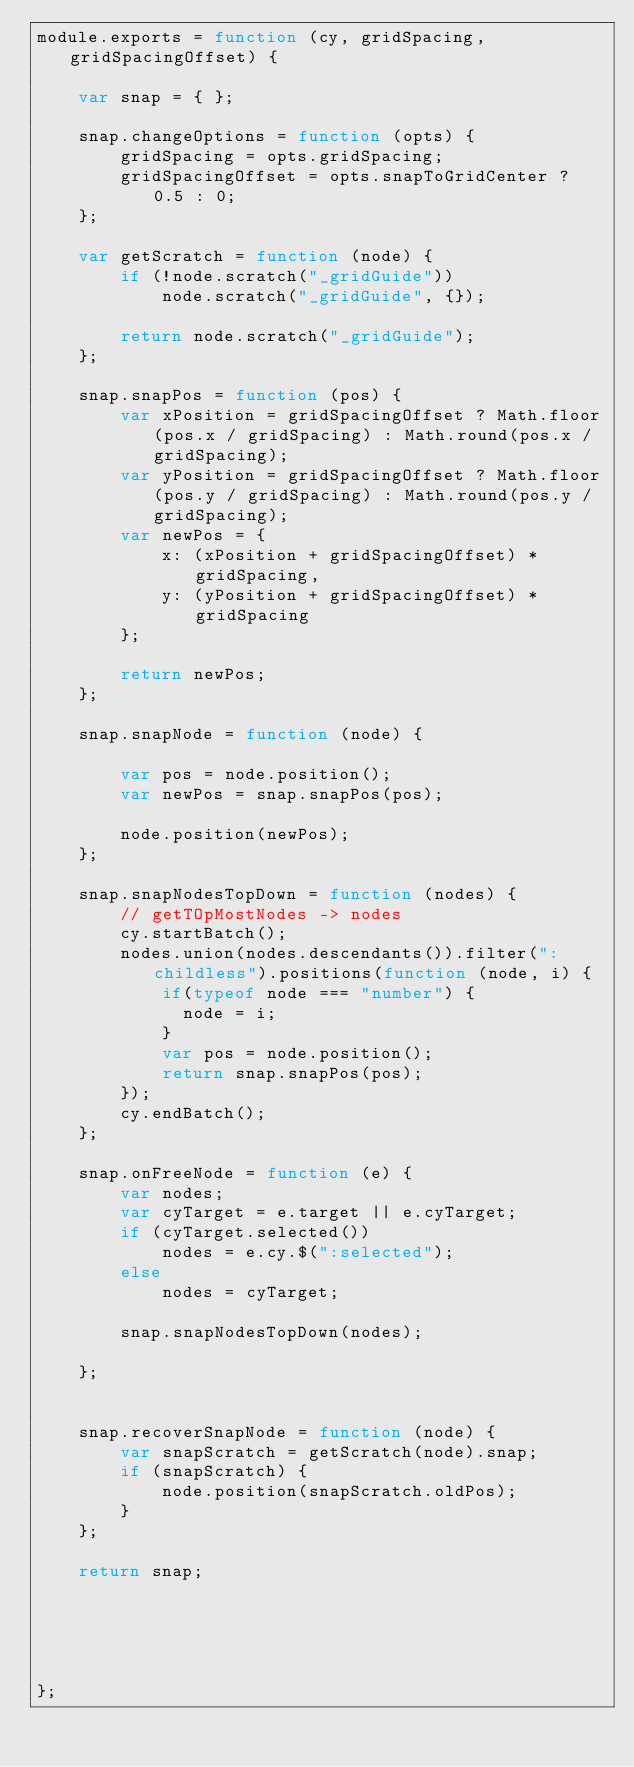<code> <loc_0><loc_0><loc_500><loc_500><_JavaScript_>module.exports = function (cy, gridSpacing, gridSpacingOffset) {

    var snap = { };

    snap.changeOptions = function (opts) {
        gridSpacing = opts.gridSpacing;
        gridSpacingOffset = opts.snapToGridCenter ? 0.5 : 0;
    };

    var getScratch = function (node) {
        if (!node.scratch("_gridGuide"))
            node.scratch("_gridGuide", {});

        return node.scratch("_gridGuide");
    };

    snap.snapPos = function (pos) {
        var xPosition = gridSpacingOffset ? Math.floor(pos.x / gridSpacing) : Math.round(pos.x / gridSpacing);
        var yPosition = gridSpacingOffset ? Math.floor(pos.y / gridSpacing) : Math.round(pos.y / gridSpacing);
        var newPos = {
            x: (xPosition + gridSpacingOffset) * gridSpacing,
            y: (yPosition + gridSpacingOffset) * gridSpacing
        };

        return newPos;
    };

    snap.snapNode = function (node) {

        var pos = node.position();
        var newPos = snap.snapPos(pos);

        node.position(newPos);
    };

    snap.snapNodesTopDown = function (nodes) {
        // getTOpMostNodes -> nodes
        cy.startBatch();
        nodes.union(nodes.descendants()).filter(":childless").positions(function (node, i) {
            if(typeof node === "number") {
              node = i;
            }
            var pos = node.position();
            return snap.snapPos(pos);
        });
        cy.endBatch();
    };

    snap.onFreeNode = function (e) {
        var nodes;
        var cyTarget = e.target || e.cyTarget;
        if (cyTarget.selected())
            nodes = e.cy.$(":selected");
        else
            nodes = cyTarget;

        snap.snapNodesTopDown(nodes);

    };


    snap.recoverSnapNode = function (node) {
        var snapScratch = getScratch(node).snap;
        if (snapScratch) {
            node.position(snapScratch.oldPos);
        }
    };

    return snap;





};
</code> 